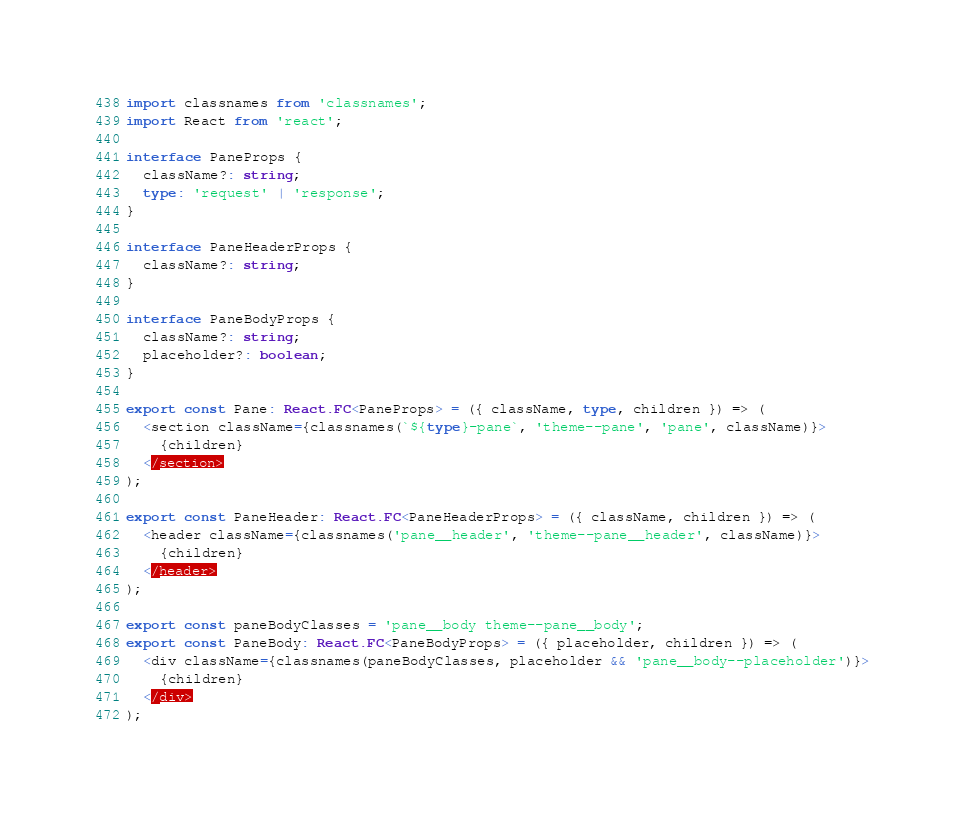<code> <loc_0><loc_0><loc_500><loc_500><_TypeScript_>import classnames from 'classnames';
import React from 'react';

interface PaneProps {
  className?: string;
  type: 'request' | 'response';
}

interface PaneHeaderProps {
  className?: string;
}

interface PaneBodyProps {
  className?: string;
  placeholder?: boolean;
}

export const Pane: React.FC<PaneProps> = ({ className, type, children }) => (
  <section className={classnames(`${type}-pane`, 'theme--pane', 'pane', className)}>
    {children}
  </section>
);

export const PaneHeader: React.FC<PaneHeaderProps> = ({ className, children }) => (
  <header className={classnames('pane__header', 'theme--pane__header', className)}>
    {children}
  </header>
);

export const paneBodyClasses = 'pane__body theme--pane__body';
export const PaneBody: React.FC<PaneBodyProps> = ({ placeholder, children }) => (
  <div className={classnames(paneBodyClasses, placeholder && 'pane__body--placeholder')}>
    {children}
  </div>
);
</code> 